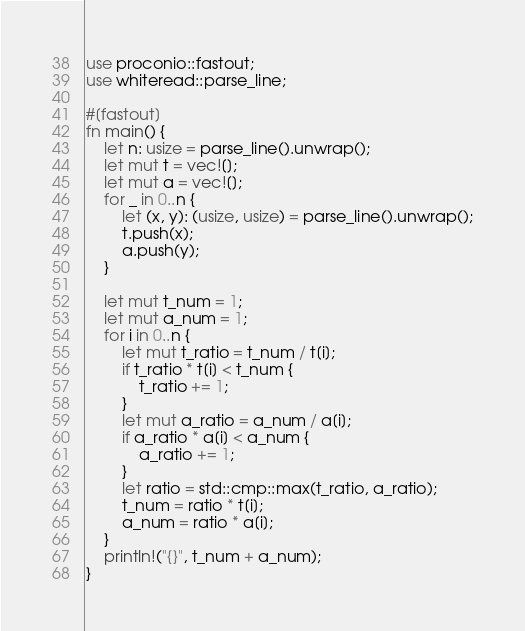<code> <loc_0><loc_0><loc_500><loc_500><_Rust_>use proconio::fastout;
use whiteread::parse_line;

#[fastout]
fn main() {
    let n: usize = parse_line().unwrap();
    let mut t = vec![];
    let mut a = vec![];
    for _ in 0..n {
        let (x, y): (usize, usize) = parse_line().unwrap();
        t.push(x);
        a.push(y);
    }

    let mut t_num = 1;
    let mut a_num = 1;
    for i in 0..n {
        let mut t_ratio = t_num / t[i];
        if t_ratio * t[i] < t_num {
            t_ratio += 1;
        }
        let mut a_ratio = a_num / a[i];
        if a_ratio * a[i] < a_num {
            a_ratio += 1;
        }
        let ratio = std::cmp::max(t_ratio, a_ratio);
        t_num = ratio * t[i];
        a_num = ratio * a[i];
    }
    println!("{}", t_num + a_num);
}
</code> 